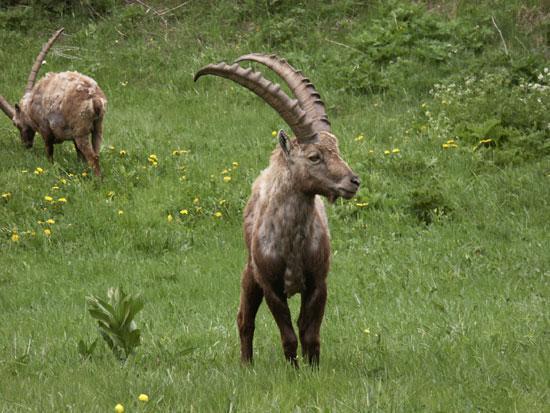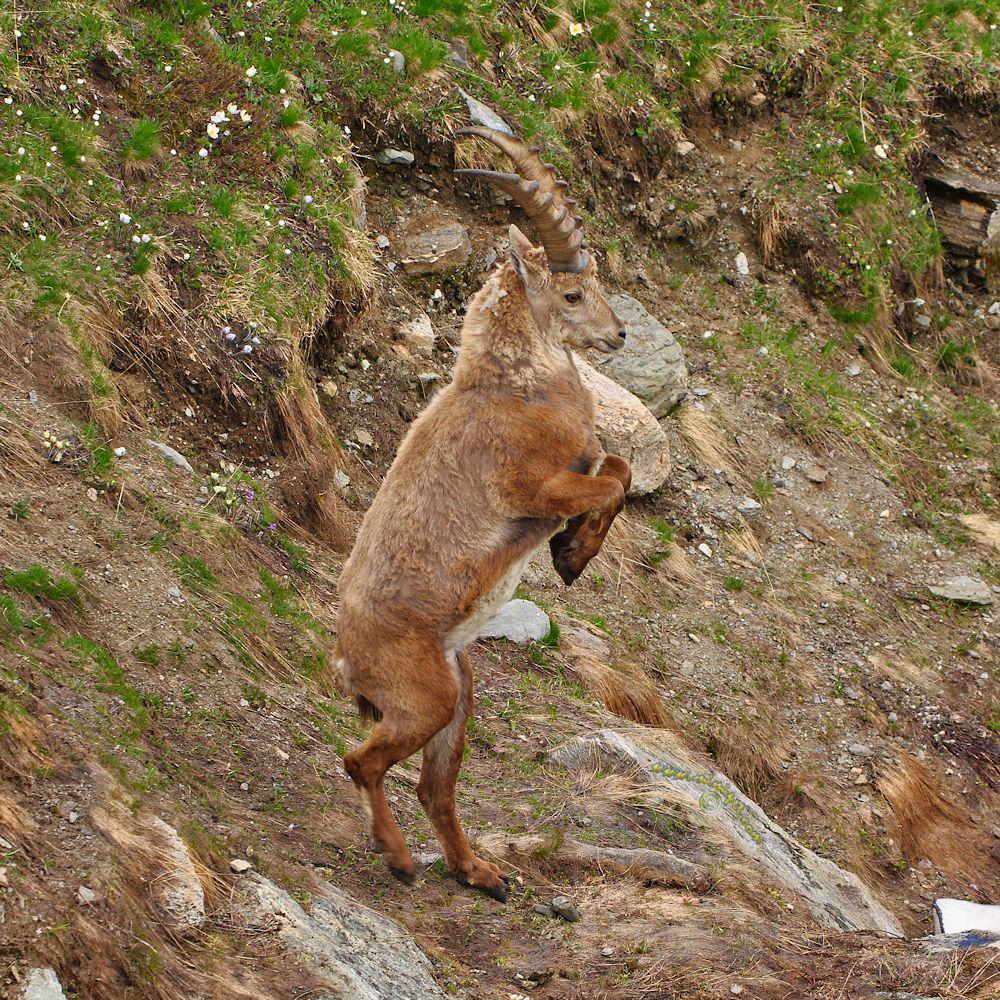The first image is the image on the left, the second image is the image on the right. Considering the images on both sides, is "The left image shows two goats that are touching each other." valid? Answer yes or no. No. The first image is the image on the left, the second image is the image on the right. Examine the images to the left and right. Is the description "The left and right image contains a total of three goats." accurate? Answer yes or no. Yes. 